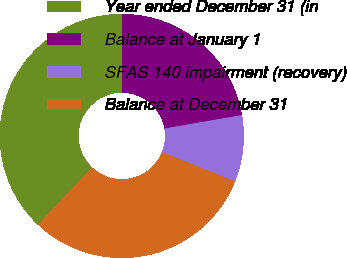<chart> <loc_0><loc_0><loc_500><loc_500><pie_chart><fcel>Year ended December 31 (in<fcel>Balance at January 1<fcel>SFAS 140 impairment (recovery)<fcel>Balance at December 31<nl><fcel>37.99%<fcel>22.2%<fcel>8.8%<fcel>31.01%<nl></chart> 